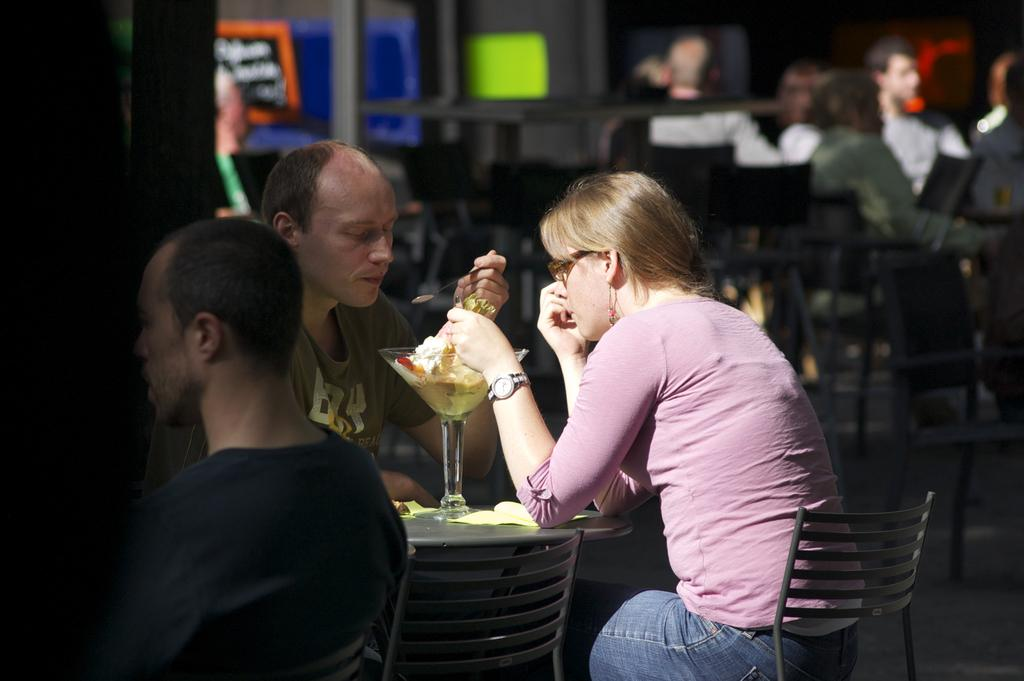What is the gender of the person on the right side of the image? There is a beautiful woman on the right side of the image. What is the woman doing in the image? The woman is sitting on the right side and eating an ice cream. What type of clothing is the woman wearing? The woman is wearing a t-shirt and trousers. Who else is present in the image? There is a man in the image. What is the man doing in the image? The man is eating an ice cream and is on the left side. How does the wind affect the ice cream in the image? There is no wind present in the image, so it cannot affect the ice cream. Does the boy in the image have any pockets in his clothing? There is no boy present in the image, so it is not possible to determine if he has any pockets in his clothing. 